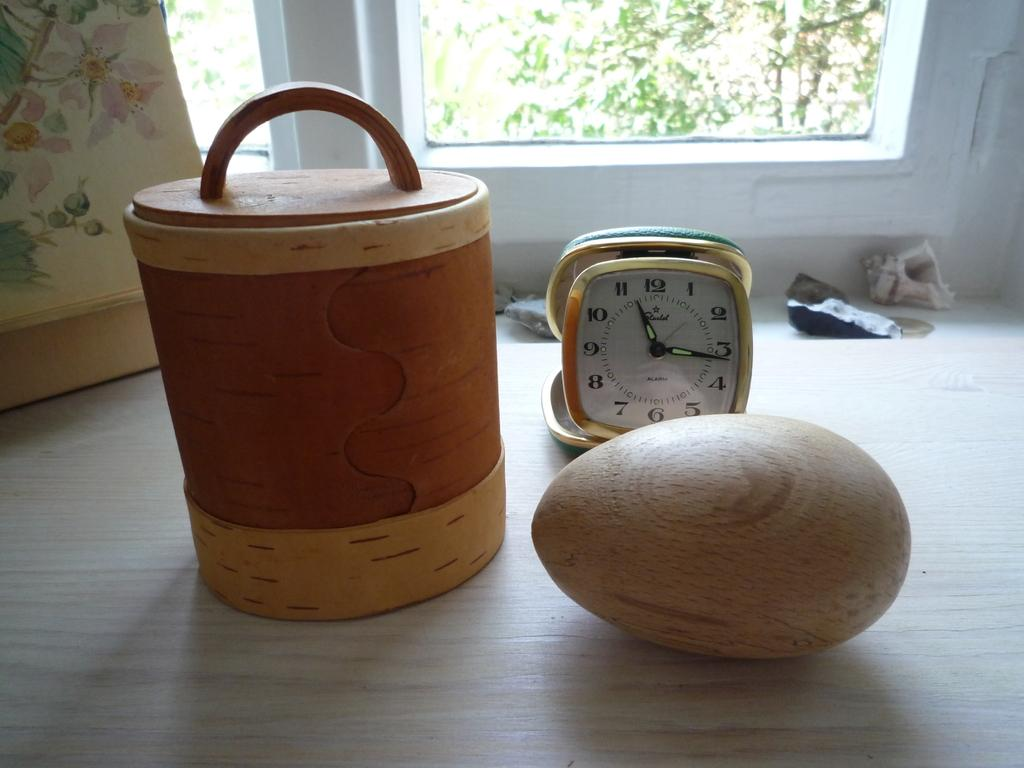<image>
Write a terse but informative summary of the picture. A Starlet alarm clock sits on a counter with a basket and a wooden egg. 